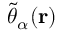Convert formula to latex. <formula><loc_0><loc_0><loc_500><loc_500>\tilde { \theta } _ { \alpha } ( r )</formula> 